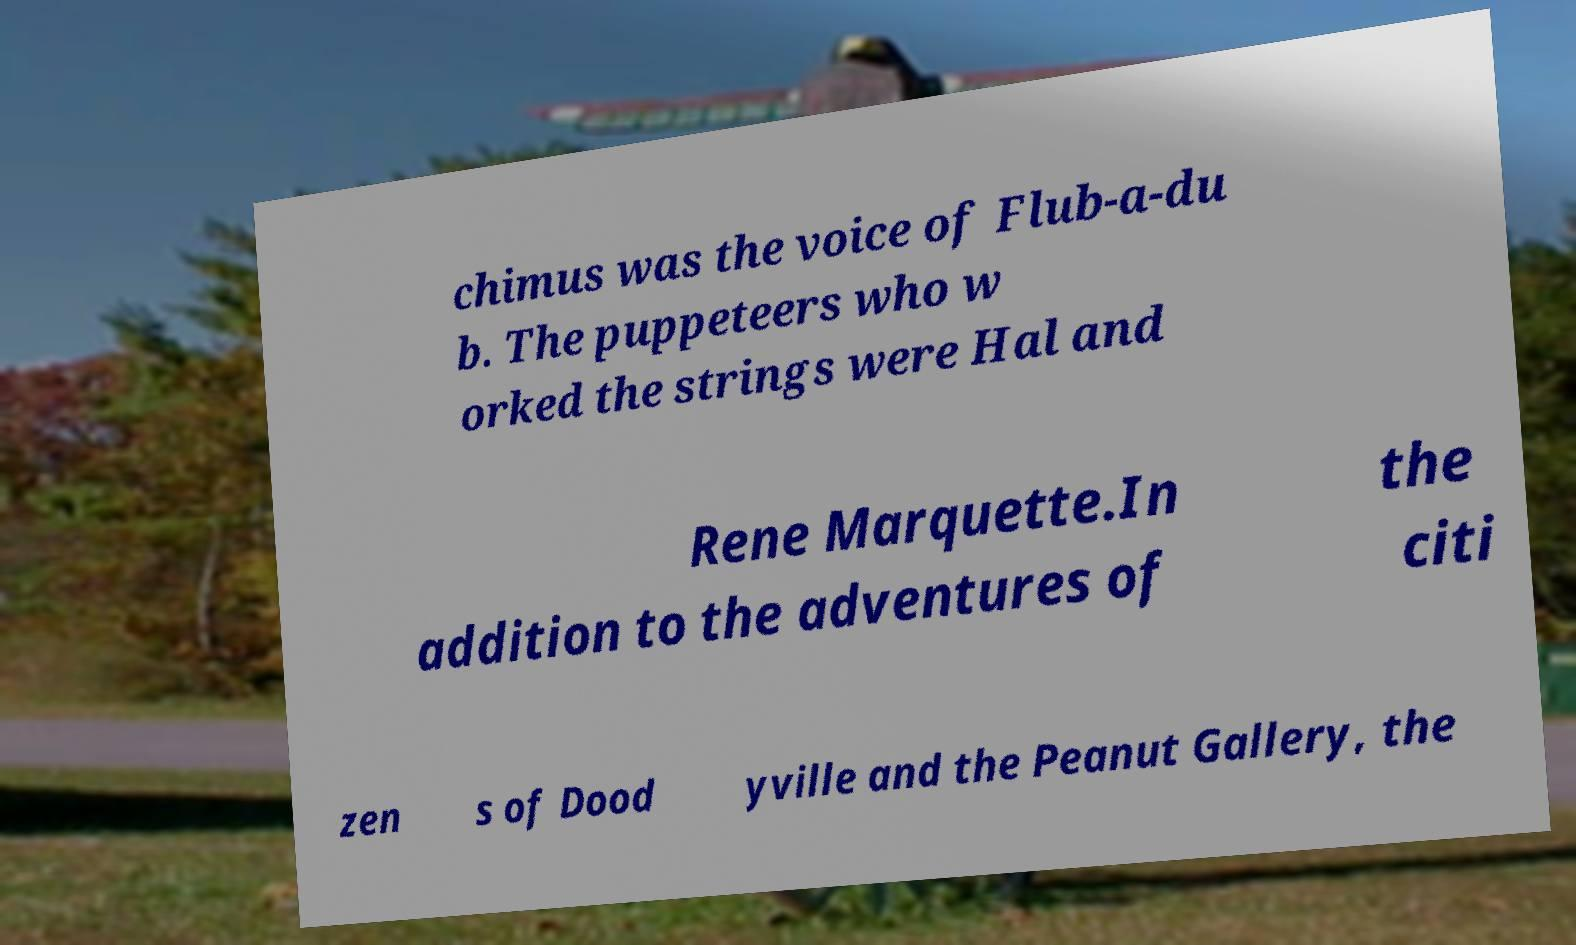What messages or text are displayed in this image? I need them in a readable, typed format. chimus was the voice of Flub-a-du b. The puppeteers who w orked the strings were Hal and Rene Marquette.In addition to the adventures of the citi zen s of Dood yville and the Peanut Gallery, the 